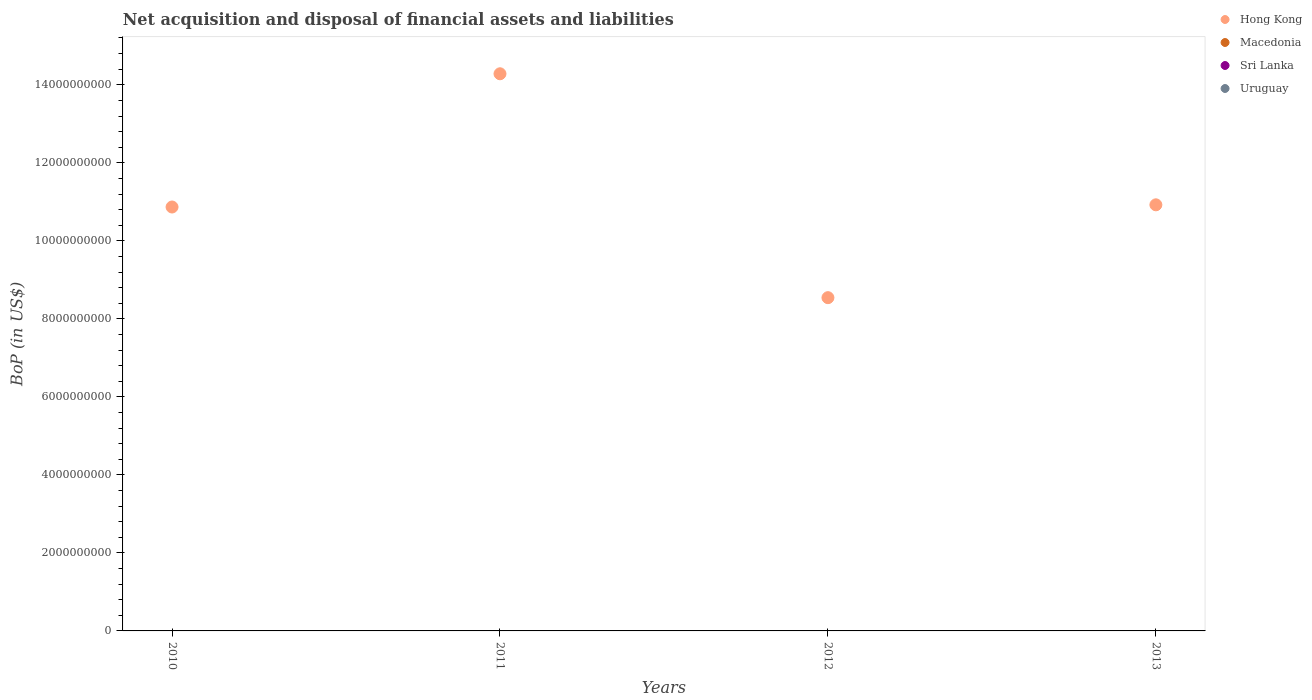Is the number of dotlines equal to the number of legend labels?
Offer a very short reply. No. What is the Balance of Payments in Macedonia in 2010?
Your answer should be compact. 0. Across all years, what is the minimum Balance of Payments in Uruguay?
Provide a succinct answer. 0. In which year was the Balance of Payments in Hong Kong maximum?
Your response must be concise. 2011. What is the total Balance of Payments in Macedonia in the graph?
Give a very brief answer. 0. What is the difference between the Balance of Payments in Macedonia in 2011 and the Balance of Payments in Hong Kong in 2010?
Provide a short and direct response. -1.09e+1. What is the average Balance of Payments in Sri Lanka per year?
Offer a very short reply. 0. What is the ratio of the Balance of Payments in Hong Kong in 2011 to that in 2012?
Your answer should be very brief. 1.67. What is the difference between the highest and the second highest Balance of Payments in Hong Kong?
Ensure brevity in your answer.  3.36e+09. What is the difference between the highest and the lowest Balance of Payments in Hong Kong?
Your answer should be very brief. 5.74e+09. In how many years, is the Balance of Payments in Uruguay greater than the average Balance of Payments in Uruguay taken over all years?
Your answer should be compact. 0. Is it the case that in every year, the sum of the Balance of Payments in Macedonia and Balance of Payments in Hong Kong  is greater than the sum of Balance of Payments in Uruguay and Balance of Payments in Sri Lanka?
Your answer should be very brief. No. Is it the case that in every year, the sum of the Balance of Payments in Sri Lanka and Balance of Payments in Macedonia  is greater than the Balance of Payments in Uruguay?
Your answer should be compact. No. Does the Balance of Payments in Uruguay monotonically increase over the years?
Provide a short and direct response. No. Is the Balance of Payments in Hong Kong strictly less than the Balance of Payments in Macedonia over the years?
Offer a terse response. No. How many dotlines are there?
Ensure brevity in your answer.  1. Where does the legend appear in the graph?
Provide a succinct answer. Top right. How many legend labels are there?
Provide a short and direct response. 4. What is the title of the graph?
Offer a very short reply. Net acquisition and disposal of financial assets and liabilities. Does "Myanmar" appear as one of the legend labels in the graph?
Provide a succinct answer. No. What is the label or title of the X-axis?
Provide a succinct answer. Years. What is the label or title of the Y-axis?
Offer a very short reply. BoP (in US$). What is the BoP (in US$) in Hong Kong in 2010?
Offer a very short reply. 1.09e+1. What is the BoP (in US$) in Macedonia in 2010?
Your response must be concise. 0. What is the BoP (in US$) in Sri Lanka in 2010?
Your response must be concise. 0. What is the BoP (in US$) of Uruguay in 2010?
Ensure brevity in your answer.  0. What is the BoP (in US$) of Hong Kong in 2011?
Offer a very short reply. 1.43e+1. What is the BoP (in US$) in Macedonia in 2011?
Offer a very short reply. 0. What is the BoP (in US$) of Sri Lanka in 2011?
Ensure brevity in your answer.  0. What is the BoP (in US$) of Hong Kong in 2012?
Your answer should be compact. 8.54e+09. What is the BoP (in US$) of Sri Lanka in 2012?
Give a very brief answer. 0. What is the BoP (in US$) in Uruguay in 2012?
Provide a succinct answer. 0. What is the BoP (in US$) in Hong Kong in 2013?
Give a very brief answer. 1.09e+1. What is the BoP (in US$) in Uruguay in 2013?
Provide a short and direct response. 0. Across all years, what is the maximum BoP (in US$) of Hong Kong?
Give a very brief answer. 1.43e+1. Across all years, what is the minimum BoP (in US$) of Hong Kong?
Ensure brevity in your answer.  8.54e+09. What is the total BoP (in US$) in Hong Kong in the graph?
Keep it short and to the point. 4.46e+1. What is the total BoP (in US$) of Sri Lanka in the graph?
Keep it short and to the point. 0. What is the difference between the BoP (in US$) of Hong Kong in 2010 and that in 2011?
Ensure brevity in your answer.  -3.42e+09. What is the difference between the BoP (in US$) in Hong Kong in 2010 and that in 2012?
Offer a terse response. 2.32e+09. What is the difference between the BoP (in US$) in Hong Kong in 2010 and that in 2013?
Your answer should be very brief. -5.62e+07. What is the difference between the BoP (in US$) of Hong Kong in 2011 and that in 2012?
Give a very brief answer. 5.74e+09. What is the difference between the BoP (in US$) in Hong Kong in 2011 and that in 2013?
Give a very brief answer. 3.36e+09. What is the difference between the BoP (in US$) of Hong Kong in 2012 and that in 2013?
Your response must be concise. -2.38e+09. What is the average BoP (in US$) in Hong Kong per year?
Ensure brevity in your answer.  1.12e+1. What is the average BoP (in US$) in Macedonia per year?
Ensure brevity in your answer.  0. What is the average BoP (in US$) of Uruguay per year?
Keep it short and to the point. 0. What is the ratio of the BoP (in US$) in Hong Kong in 2010 to that in 2011?
Offer a terse response. 0.76. What is the ratio of the BoP (in US$) in Hong Kong in 2010 to that in 2012?
Offer a terse response. 1.27. What is the ratio of the BoP (in US$) in Hong Kong in 2010 to that in 2013?
Keep it short and to the point. 0.99. What is the ratio of the BoP (in US$) of Hong Kong in 2011 to that in 2012?
Provide a short and direct response. 1.67. What is the ratio of the BoP (in US$) of Hong Kong in 2011 to that in 2013?
Your response must be concise. 1.31. What is the ratio of the BoP (in US$) in Hong Kong in 2012 to that in 2013?
Your answer should be compact. 0.78. What is the difference between the highest and the second highest BoP (in US$) in Hong Kong?
Make the answer very short. 3.36e+09. What is the difference between the highest and the lowest BoP (in US$) of Hong Kong?
Provide a succinct answer. 5.74e+09. 